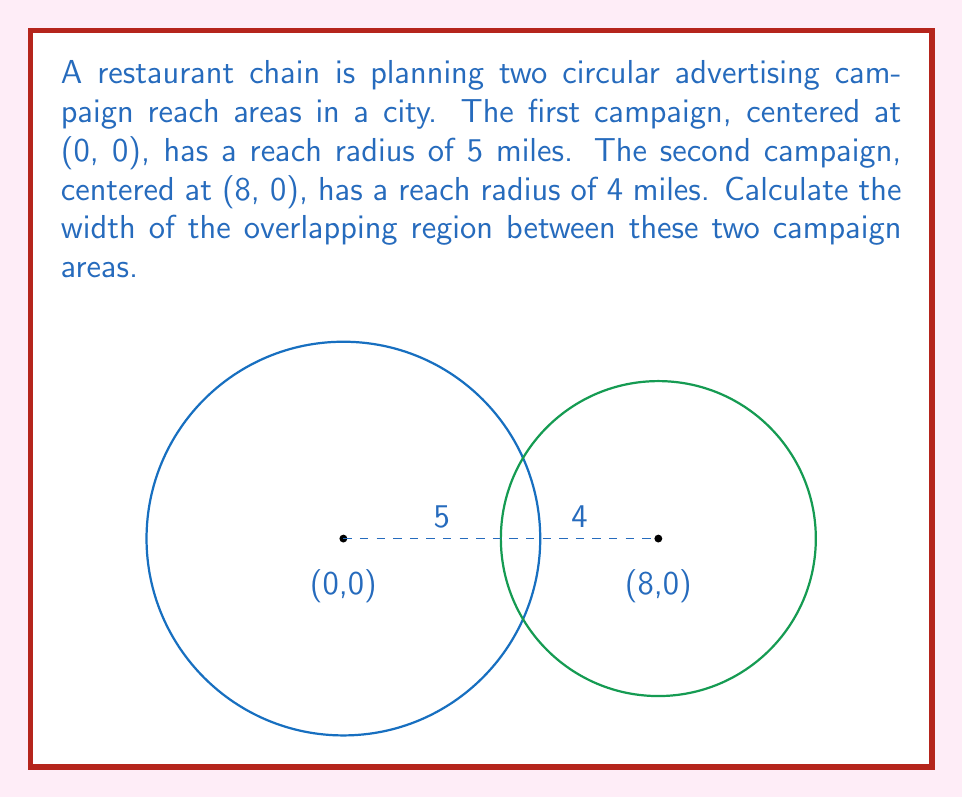Give your solution to this math problem. Let's approach this step-by-step:

1) The two circles represent the reach areas of the campaigns. We need to find the width of their intersection.

2) The centers of the circles are 8 miles apart (from (0,0) to (8,0)).

3) The width of the overlapping region is the sum of the radii minus the distance between the centers:
   $$(5 + 4) - 8 = 1$$

4) However, this is only true if the circles intersect. We need to verify this:

5) For circles to intersect, the distance between their centers must be less than the sum of their radii:
   $$\text{Distance} < r_1 + r_2$$
   $$8 < 5 + 4 = 9$$

6) Since 8 < 9, the circles do intersect.

7) We can also calculate this width using the formula for the distance between intersection points:

   $$d = 2\sqrt{\frac{(r_1+r_2)^2-(a^2)}{4} \cdot \frac{(a^2)-(r_1-r_2)^2}{4a^2}}$$

   Where $a$ is the distance between centers, and $r_1$ and $r_2$ are the radii.

8) Plugging in our values:

   $$d = 2\sqrt{\frac{(5+4)^2-(8^2)}{4} \cdot \frac{(8^2)-(5-4)^2}{4(8^2)}}$$

9) Simplifying:

   $$d = 2\sqrt{\frac{81-64}{4} \cdot \frac{64-1}{256}} = 2\sqrt{\frac{17}{4} \cdot \frac{63}{256}} = 1$$

This confirms our initial calculation.
Answer: 1 mile 